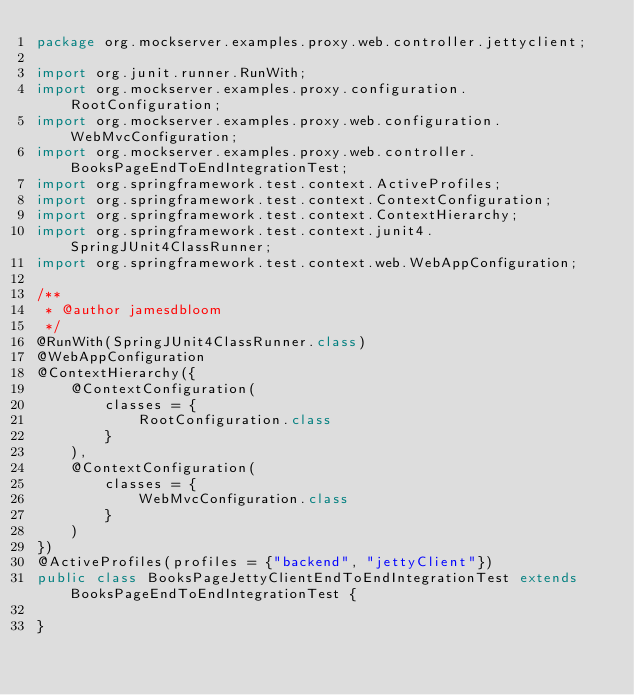<code> <loc_0><loc_0><loc_500><loc_500><_Java_>package org.mockserver.examples.proxy.web.controller.jettyclient;

import org.junit.runner.RunWith;
import org.mockserver.examples.proxy.configuration.RootConfiguration;
import org.mockserver.examples.proxy.web.configuration.WebMvcConfiguration;
import org.mockserver.examples.proxy.web.controller.BooksPageEndToEndIntegrationTest;
import org.springframework.test.context.ActiveProfiles;
import org.springframework.test.context.ContextConfiguration;
import org.springframework.test.context.ContextHierarchy;
import org.springframework.test.context.junit4.SpringJUnit4ClassRunner;
import org.springframework.test.context.web.WebAppConfiguration;

/**
 * @author jamesdbloom
 */
@RunWith(SpringJUnit4ClassRunner.class)
@WebAppConfiguration
@ContextHierarchy({
    @ContextConfiguration(
        classes = {
            RootConfiguration.class
        }
    ),
    @ContextConfiguration(
        classes = {
            WebMvcConfiguration.class
        }
    )
})
@ActiveProfiles(profiles = {"backend", "jettyClient"})
public class BooksPageJettyClientEndToEndIntegrationTest extends BooksPageEndToEndIntegrationTest {

}
</code> 